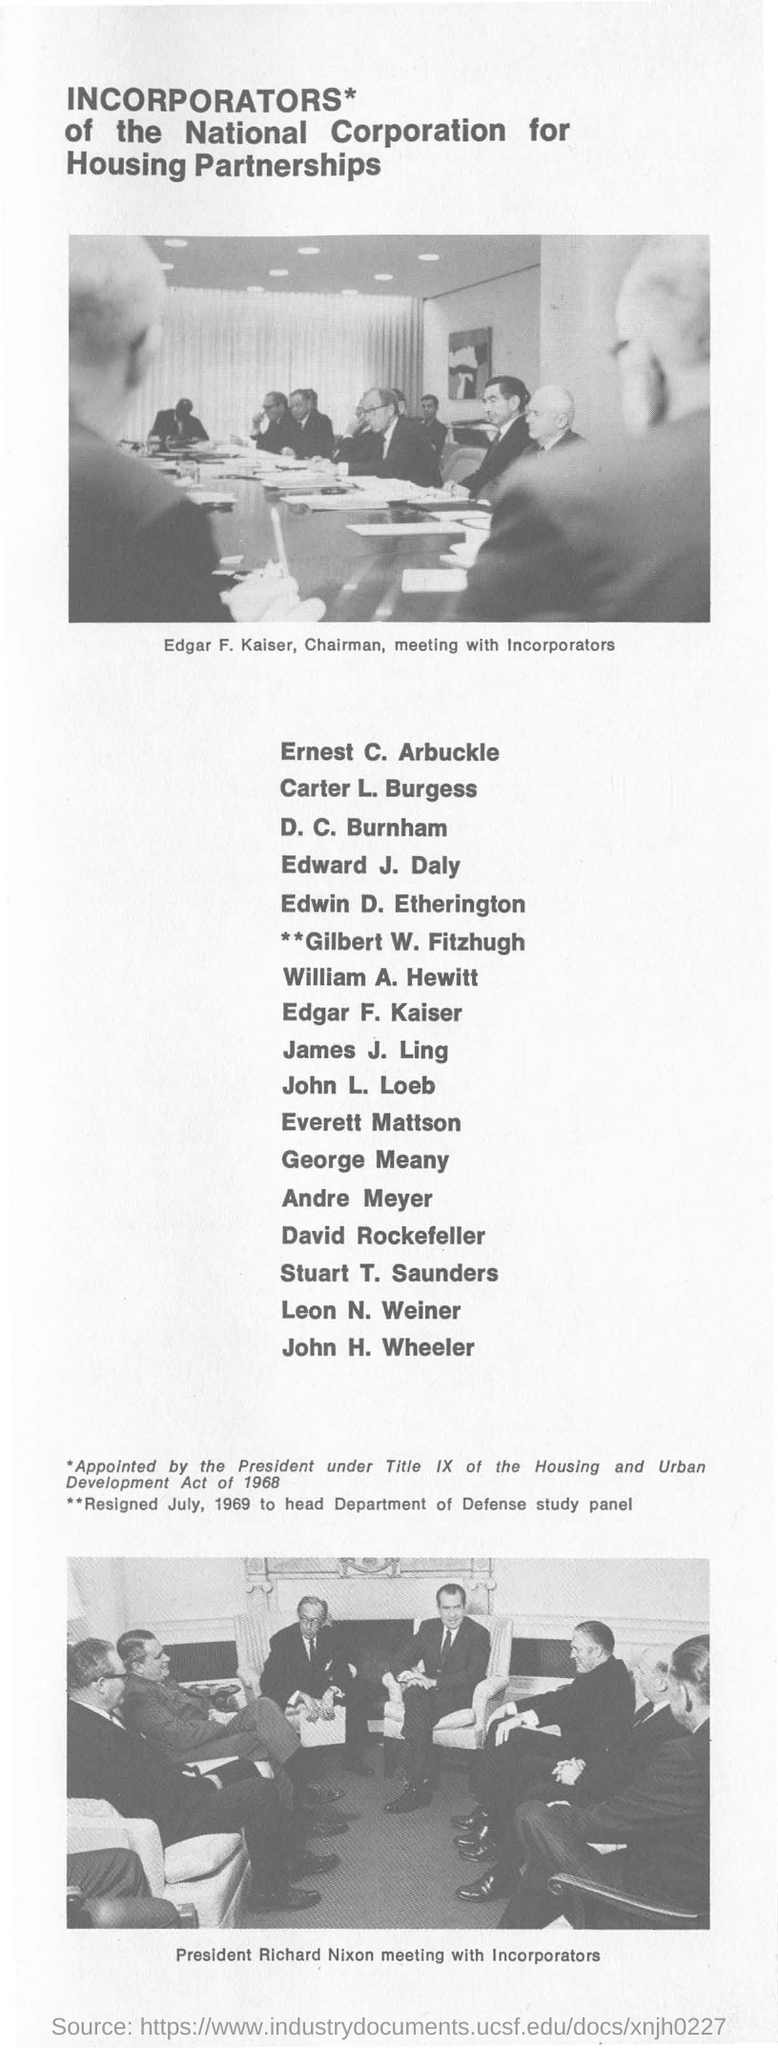Who is the Chairman?
Your answer should be very brief. Edgar F. Kaiser. 